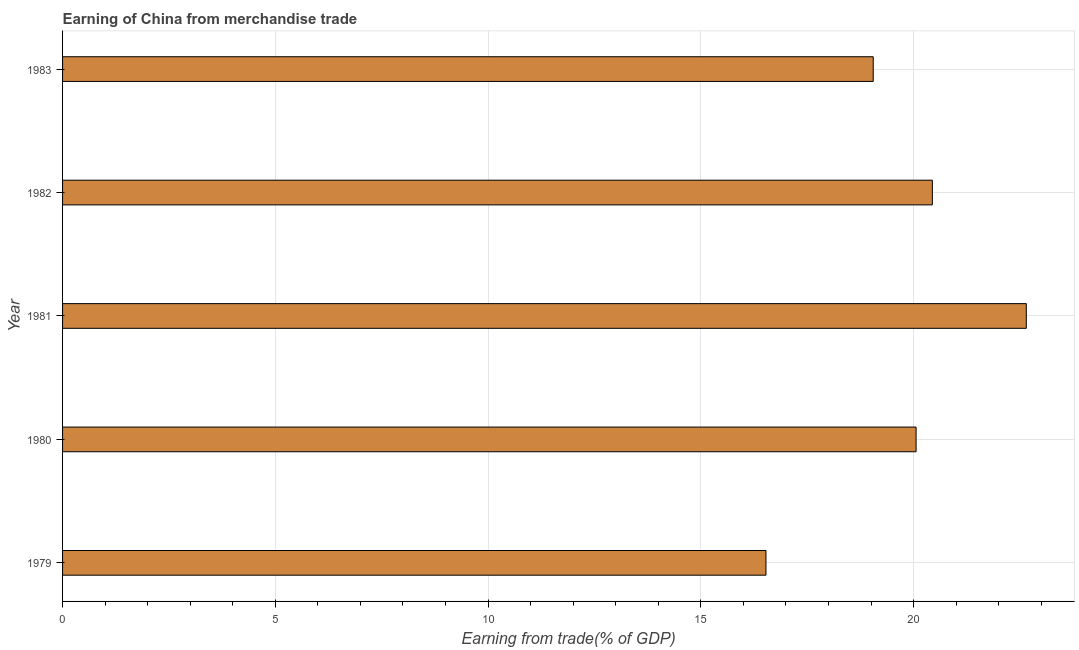Does the graph contain any zero values?
Keep it short and to the point. No. What is the title of the graph?
Your answer should be compact. Earning of China from merchandise trade. What is the label or title of the X-axis?
Your response must be concise. Earning from trade(% of GDP). What is the earning from merchandise trade in 1980?
Give a very brief answer. 20.06. Across all years, what is the maximum earning from merchandise trade?
Your response must be concise. 22.65. Across all years, what is the minimum earning from merchandise trade?
Your answer should be very brief. 16.53. In which year was the earning from merchandise trade maximum?
Provide a short and direct response. 1981. In which year was the earning from merchandise trade minimum?
Your response must be concise. 1979. What is the sum of the earning from merchandise trade?
Offer a very short reply. 98.73. What is the difference between the earning from merchandise trade in 1982 and 1983?
Ensure brevity in your answer.  1.39. What is the average earning from merchandise trade per year?
Offer a terse response. 19.75. What is the median earning from merchandise trade?
Your answer should be very brief. 20.06. In how many years, is the earning from merchandise trade greater than 20 %?
Offer a terse response. 3. Do a majority of the years between 1982 and 1981 (inclusive) have earning from merchandise trade greater than 2 %?
Your answer should be very brief. No. What is the ratio of the earning from merchandise trade in 1979 to that in 1982?
Your answer should be very brief. 0.81. Is the earning from merchandise trade in 1980 less than that in 1983?
Your answer should be compact. No. Is the difference between the earning from merchandise trade in 1979 and 1982 greater than the difference between any two years?
Offer a terse response. No. What is the difference between the highest and the second highest earning from merchandise trade?
Your answer should be compact. 2.21. Is the sum of the earning from merchandise trade in 1980 and 1982 greater than the maximum earning from merchandise trade across all years?
Make the answer very short. Yes. What is the difference between the highest and the lowest earning from merchandise trade?
Your answer should be very brief. 6.12. In how many years, is the earning from merchandise trade greater than the average earning from merchandise trade taken over all years?
Ensure brevity in your answer.  3. Are all the bars in the graph horizontal?
Your answer should be very brief. Yes. What is the difference between two consecutive major ticks on the X-axis?
Your response must be concise. 5. Are the values on the major ticks of X-axis written in scientific E-notation?
Offer a terse response. No. What is the Earning from trade(% of GDP) in 1979?
Provide a short and direct response. 16.53. What is the Earning from trade(% of GDP) of 1980?
Ensure brevity in your answer.  20.06. What is the Earning from trade(% of GDP) in 1981?
Give a very brief answer. 22.65. What is the Earning from trade(% of GDP) in 1982?
Provide a short and direct response. 20.44. What is the Earning from trade(% of GDP) of 1983?
Ensure brevity in your answer.  19.05. What is the difference between the Earning from trade(% of GDP) in 1979 and 1980?
Your response must be concise. -3.53. What is the difference between the Earning from trade(% of GDP) in 1979 and 1981?
Your answer should be very brief. -6.12. What is the difference between the Earning from trade(% of GDP) in 1979 and 1982?
Make the answer very short. -3.91. What is the difference between the Earning from trade(% of GDP) in 1979 and 1983?
Give a very brief answer. -2.52. What is the difference between the Earning from trade(% of GDP) in 1980 and 1981?
Offer a very short reply. -2.59. What is the difference between the Earning from trade(% of GDP) in 1980 and 1982?
Make the answer very short. -0.38. What is the difference between the Earning from trade(% of GDP) in 1980 and 1983?
Your answer should be compact. 1.01. What is the difference between the Earning from trade(% of GDP) in 1981 and 1982?
Ensure brevity in your answer.  2.21. What is the difference between the Earning from trade(% of GDP) in 1981 and 1983?
Give a very brief answer. 3.6. What is the difference between the Earning from trade(% of GDP) in 1982 and 1983?
Provide a succinct answer. 1.39. What is the ratio of the Earning from trade(% of GDP) in 1979 to that in 1980?
Your response must be concise. 0.82. What is the ratio of the Earning from trade(% of GDP) in 1979 to that in 1981?
Provide a short and direct response. 0.73. What is the ratio of the Earning from trade(% of GDP) in 1979 to that in 1982?
Provide a succinct answer. 0.81. What is the ratio of the Earning from trade(% of GDP) in 1979 to that in 1983?
Your answer should be compact. 0.87. What is the ratio of the Earning from trade(% of GDP) in 1980 to that in 1981?
Make the answer very short. 0.89. What is the ratio of the Earning from trade(% of GDP) in 1980 to that in 1982?
Ensure brevity in your answer.  0.98. What is the ratio of the Earning from trade(% of GDP) in 1980 to that in 1983?
Provide a succinct answer. 1.05. What is the ratio of the Earning from trade(% of GDP) in 1981 to that in 1982?
Ensure brevity in your answer.  1.11. What is the ratio of the Earning from trade(% of GDP) in 1981 to that in 1983?
Provide a short and direct response. 1.19. What is the ratio of the Earning from trade(% of GDP) in 1982 to that in 1983?
Give a very brief answer. 1.07. 